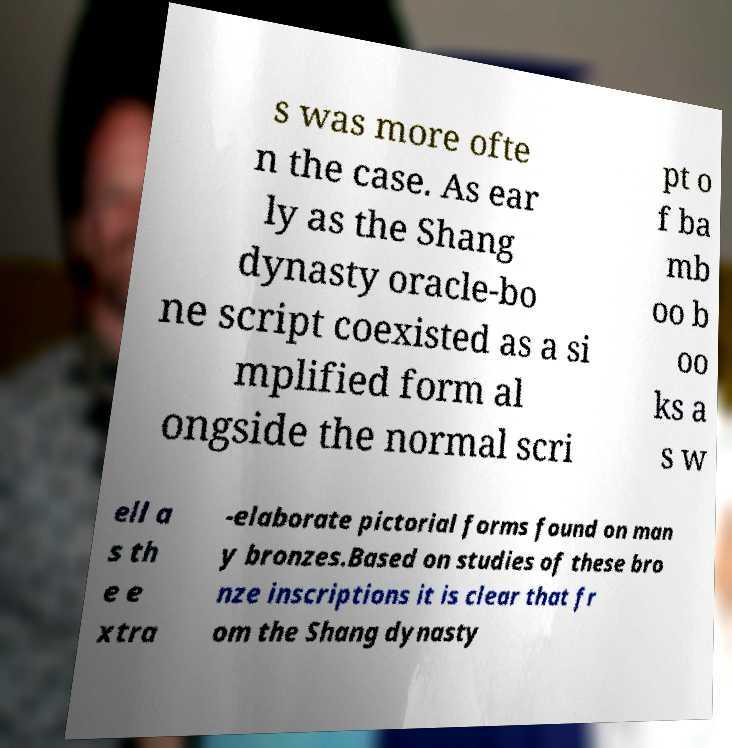Can you read and provide the text displayed in the image?This photo seems to have some interesting text. Can you extract and type it out for me? s was more ofte n the case. As ear ly as the Shang dynasty oracle-bo ne script coexisted as a si mplified form al ongside the normal scri pt o f ba mb oo b oo ks a s w ell a s th e e xtra -elaborate pictorial forms found on man y bronzes.Based on studies of these bro nze inscriptions it is clear that fr om the Shang dynasty 